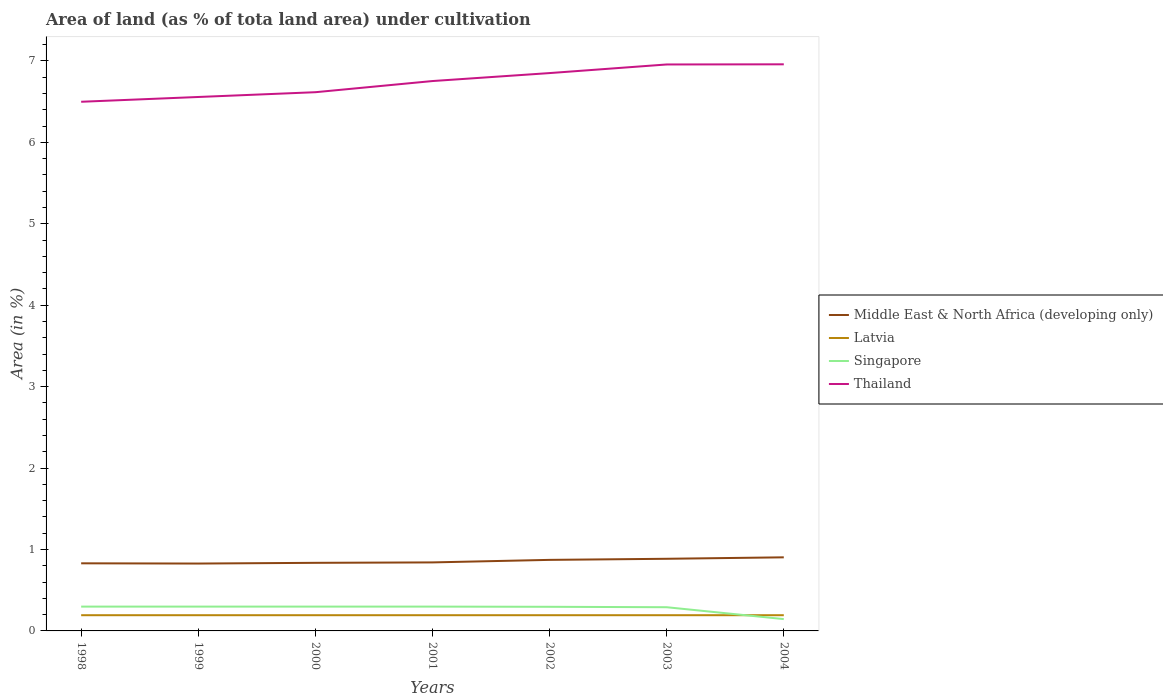Does the line corresponding to Middle East & North Africa (developing only) intersect with the line corresponding to Latvia?
Ensure brevity in your answer.  No. Across all years, what is the maximum percentage of land under cultivation in Latvia?
Keep it short and to the point. 0.19. What is the total percentage of land under cultivation in Thailand in the graph?
Your answer should be very brief. -0.06. What is the difference between the highest and the second highest percentage of land under cultivation in Middle East & North Africa (developing only)?
Give a very brief answer. 0.08. What is the difference between the highest and the lowest percentage of land under cultivation in Thailand?
Your answer should be compact. 4. How many years are there in the graph?
Provide a succinct answer. 7. Are the values on the major ticks of Y-axis written in scientific E-notation?
Your answer should be compact. No. Does the graph contain any zero values?
Make the answer very short. No. What is the title of the graph?
Offer a very short reply. Area of land (as % of tota land area) under cultivation. What is the label or title of the X-axis?
Keep it short and to the point. Years. What is the label or title of the Y-axis?
Provide a short and direct response. Area (in %). What is the Area (in %) in Middle East & North Africa (developing only) in 1998?
Ensure brevity in your answer.  0.83. What is the Area (in %) in Latvia in 1998?
Ensure brevity in your answer.  0.19. What is the Area (in %) of Singapore in 1998?
Make the answer very short. 0.3. What is the Area (in %) in Thailand in 1998?
Your answer should be compact. 6.5. What is the Area (in %) of Middle East & North Africa (developing only) in 1999?
Your answer should be compact. 0.83. What is the Area (in %) in Latvia in 1999?
Ensure brevity in your answer.  0.19. What is the Area (in %) of Singapore in 1999?
Offer a very short reply. 0.3. What is the Area (in %) of Thailand in 1999?
Offer a very short reply. 6.56. What is the Area (in %) of Middle East & North Africa (developing only) in 2000?
Offer a very short reply. 0.84. What is the Area (in %) in Latvia in 2000?
Make the answer very short. 0.19. What is the Area (in %) of Singapore in 2000?
Give a very brief answer. 0.3. What is the Area (in %) in Thailand in 2000?
Your answer should be very brief. 6.62. What is the Area (in %) in Middle East & North Africa (developing only) in 2001?
Provide a succinct answer. 0.84. What is the Area (in %) of Latvia in 2001?
Offer a terse response. 0.19. What is the Area (in %) of Singapore in 2001?
Ensure brevity in your answer.  0.3. What is the Area (in %) of Thailand in 2001?
Offer a very short reply. 6.75. What is the Area (in %) of Middle East & North Africa (developing only) in 2002?
Provide a succinct answer. 0.87. What is the Area (in %) in Latvia in 2002?
Keep it short and to the point. 0.19. What is the Area (in %) in Singapore in 2002?
Provide a short and direct response. 0.3. What is the Area (in %) in Thailand in 2002?
Give a very brief answer. 6.85. What is the Area (in %) in Middle East & North Africa (developing only) in 2003?
Offer a very short reply. 0.89. What is the Area (in %) of Latvia in 2003?
Ensure brevity in your answer.  0.19. What is the Area (in %) of Singapore in 2003?
Offer a terse response. 0.29. What is the Area (in %) in Thailand in 2003?
Your answer should be compact. 6.96. What is the Area (in %) in Middle East & North Africa (developing only) in 2004?
Your answer should be very brief. 0.9. What is the Area (in %) of Latvia in 2004?
Keep it short and to the point. 0.19. What is the Area (in %) of Singapore in 2004?
Offer a terse response. 0.15. What is the Area (in %) in Thailand in 2004?
Provide a succinct answer. 6.96. Across all years, what is the maximum Area (in %) in Middle East & North Africa (developing only)?
Offer a very short reply. 0.9. Across all years, what is the maximum Area (in %) of Latvia?
Your answer should be very brief. 0.19. Across all years, what is the maximum Area (in %) in Singapore?
Provide a succinct answer. 0.3. Across all years, what is the maximum Area (in %) in Thailand?
Your answer should be very brief. 6.96. Across all years, what is the minimum Area (in %) of Middle East & North Africa (developing only)?
Offer a terse response. 0.83. Across all years, what is the minimum Area (in %) of Latvia?
Offer a very short reply. 0.19. Across all years, what is the minimum Area (in %) of Singapore?
Keep it short and to the point. 0.15. Across all years, what is the minimum Area (in %) in Thailand?
Provide a succinct answer. 6.5. What is the total Area (in %) in Middle East & North Africa (developing only) in the graph?
Provide a succinct answer. 6. What is the total Area (in %) of Latvia in the graph?
Keep it short and to the point. 1.35. What is the total Area (in %) in Singapore in the graph?
Keep it short and to the point. 1.93. What is the total Area (in %) of Thailand in the graph?
Keep it short and to the point. 47.19. What is the difference between the Area (in %) of Middle East & North Africa (developing only) in 1998 and that in 1999?
Give a very brief answer. 0. What is the difference between the Area (in %) of Singapore in 1998 and that in 1999?
Offer a very short reply. 0. What is the difference between the Area (in %) in Thailand in 1998 and that in 1999?
Your answer should be compact. -0.06. What is the difference between the Area (in %) of Middle East & North Africa (developing only) in 1998 and that in 2000?
Offer a terse response. -0.01. What is the difference between the Area (in %) of Latvia in 1998 and that in 2000?
Offer a terse response. 0. What is the difference between the Area (in %) in Thailand in 1998 and that in 2000?
Your response must be concise. -0.12. What is the difference between the Area (in %) in Middle East & North Africa (developing only) in 1998 and that in 2001?
Make the answer very short. -0.01. What is the difference between the Area (in %) of Singapore in 1998 and that in 2001?
Your response must be concise. 0. What is the difference between the Area (in %) of Thailand in 1998 and that in 2001?
Offer a very short reply. -0.25. What is the difference between the Area (in %) in Middle East & North Africa (developing only) in 1998 and that in 2002?
Your answer should be compact. -0.04. What is the difference between the Area (in %) in Latvia in 1998 and that in 2002?
Give a very brief answer. 0. What is the difference between the Area (in %) of Singapore in 1998 and that in 2002?
Your response must be concise. 0. What is the difference between the Area (in %) in Thailand in 1998 and that in 2002?
Make the answer very short. -0.35. What is the difference between the Area (in %) in Middle East & North Africa (developing only) in 1998 and that in 2003?
Offer a very short reply. -0.06. What is the difference between the Area (in %) in Latvia in 1998 and that in 2003?
Offer a terse response. 0. What is the difference between the Area (in %) in Singapore in 1998 and that in 2003?
Your answer should be very brief. 0.01. What is the difference between the Area (in %) of Thailand in 1998 and that in 2003?
Your answer should be very brief. -0.46. What is the difference between the Area (in %) of Middle East & North Africa (developing only) in 1998 and that in 2004?
Offer a terse response. -0.07. What is the difference between the Area (in %) of Latvia in 1998 and that in 2004?
Your answer should be compact. 0. What is the difference between the Area (in %) in Singapore in 1998 and that in 2004?
Give a very brief answer. 0.15. What is the difference between the Area (in %) in Thailand in 1998 and that in 2004?
Give a very brief answer. -0.46. What is the difference between the Area (in %) of Middle East & North Africa (developing only) in 1999 and that in 2000?
Ensure brevity in your answer.  -0.01. What is the difference between the Area (in %) of Latvia in 1999 and that in 2000?
Offer a terse response. 0. What is the difference between the Area (in %) in Singapore in 1999 and that in 2000?
Offer a very short reply. 0. What is the difference between the Area (in %) of Thailand in 1999 and that in 2000?
Provide a succinct answer. -0.06. What is the difference between the Area (in %) in Middle East & North Africa (developing only) in 1999 and that in 2001?
Your answer should be compact. -0.01. What is the difference between the Area (in %) of Singapore in 1999 and that in 2001?
Provide a succinct answer. 0. What is the difference between the Area (in %) in Thailand in 1999 and that in 2001?
Ensure brevity in your answer.  -0.2. What is the difference between the Area (in %) in Middle East & North Africa (developing only) in 1999 and that in 2002?
Your response must be concise. -0.05. What is the difference between the Area (in %) of Singapore in 1999 and that in 2002?
Make the answer very short. 0. What is the difference between the Area (in %) of Thailand in 1999 and that in 2002?
Keep it short and to the point. -0.29. What is the difference between the Area (in %) of Middle East & North Africa (developing only) in 1999 and that in 2003?
Your answer should be compact. -0.06. What is the difference between the Area (in %) of Singapore in 1999 and that in 2003?
Offer a terse response. 0.01. What is the difference between the Area (in %) in Thailand in 1999 and that in 2003?
Offer a terse response. -0.4. What is the difference between the Area (in %) of Middle East & North Africa (developing only) in 1999 and that in 2004?
Give a very brief answer. -0.08. What is the difference between the Area (in %) of Singapore in 1999 and that in 2004?
Provide a short and direct response. 0.15. What is the difference between the Area (in %) of Thailand in 1999 and that in 2004?
Offer a terse response. -0.4. What is the difference between the Area (in %) of Middle East & North Africa (developing only) in 2000 and that in 2001?
Provide a short and direct response. -0.01. What is the difference between the Area (in %) in Singapore in 2000 and that in 2001?
Your response must be concise. 0. What is the difference between the Area (in %) of Thailand in 2000 and that in 2001?
Provide a succinct answer. -0.14. What is the difference between the Area (in %) in Middle East & North Africa (developing only) in 2000 and that in 2002?
Ensure brevity in your answer.  -0.04. What is the difference between the Area (in %) of Latvia in 2000 and that in 2002?
Offer a very short reply. 0. What is the difference between the Area (in %) of Singapore in 2000 and that in 2002?
Give a very brief answer. 0. What is the difference between the Area (in %) of Thailand in 2000 and that in 2002?
Make the answer very short. -0.23. What is the difference between the Area (in %) in Middle East & North Africa (developing only) in 2000 and that in 2003?
Your answer should be compact. -0.05. What is the difference between the Area (in %) of Singapore in 2000 and that in 2003?
Keep it short and to the point. 0.01. What is the difference between the Area (in %) in Thailand in 2000 and that in 2003?
Your answer should be very brief. -0.34. What is the difference between the Area (in %) in Middle East & North Africa (developing only) in 2000 and that in 2004?
Keep it short and to the point. -0.07. What is the difference between the Area (in %) of Singapore in 2000 and that in 2004?
Your response must be concise. 0.15. What is the difference between the Area (in %) in Thailand in 2000 and that in 2004?
Make the answer very short. -0.34. What is the difference between the Area (in %) in Middle East & North Africa (developing only) in 2001 and that in 2002?
Keep it short and to the point. -0.03. What is the difference between the Area (in %) in Latvia in 2001 and that in 2002?
Make the answer very short. 0. What is the difference between the Area (in %) in Singapore in 2001 and that in 2002?
Offer a terse response. 0. What is the difference between the Area (in %) of Thailand in 2001 and that in 2002?
Provide a succinct answer. -0.1. What is the difference between the Area (in %) of Middle East & North Africa (developing only) in 2001 and that in 2003?
Keep it short and to the point. -0.04. What is the difference between the Area (in %) in Singapore in 2001 and that in 2003?
Your response must be concise. 0.01. What is the difference between the Area (in %) of Thailand in 2001 and that in 2003?
Offer a terse response. -0.2. What is the difference between the Area (in %) in Middle East & North Africa (developing only) in 2001 and that in 2004?
Provide a succinct answer. -0.06. What is the difference between the Area (in %) in Latvia in 2001 and that in 2004?
Give a very brief answer. 0. What is the difference between the Area (in %) in Singapore in 2001 and that in 2004?
Offer a terse response. 0.15. What is the difference between the Area (in %) in Thailand in 2001 and that in 2004?
Provide a short and direct response. -0.21. What is the difference between the Area (in %) of Middle East & North Africa (developing only) in 2002 and that in 2003?
Your answer should be compact. -0.01. What is the difference between the Area (in %) in Singapore in 2002 and that in 2003?
Your answer should be very brief. 0.01. What is the difference between the Area (in %) of Thailand in 2002 and that in 2003?
Keep it short and to the point. -0.11. What is the difference between the Area (in %) in Middle East & North Africa (developing only) in 2002 and that in 2004?
Your answer should be compact. -0.03. What is the difference between the Area (in %) in Singapore in 2002 and that in 2004?
Offer a very short reply. 0.15. What is the difference between the Area (in %) of Thailand in 2002 and that in 2004?
Give a very brief answer. -0.11. What is the difference between the Area (in %) in Middle East & North Africa (developing only) in 2003 and that in 2004?
Keep it short and to the point. -0.02. What is the difference between the Area (in %) of Singapore in 2003 and that in 2004?
Provide a short and direct response. 0.15. What is the difference between the Area (in %) in Thailand in 2003 and that in 2004?
Keep it short and to the point. -0. What is the difference between the Area (in %) of Middle East & North Africa (developing only) in 1998 and the Area (in %) of Latvia in 1999?
Make the answer very short. 0.64. What is the difference between the Area (in %) of Middle East & North Africa (developing only) in 1998 and the Area (in %) of Singapore in 1999?
Ensure brevity in your answer.  0.53. What is the difference between the Area (in %) in Middle East & North Africa (developing only) in 1998 and the Area (in %) in Thailand in 1999?
Ensure brevity in your answer.  -5.73. What is the difference between the Area (in %) in Latvia in 1998 and the Area (in %) in Singapore in 1999?
Your answer should be very brief. -0.11. What is the difference between the Area (in %) of Latvia in 1998 and the Area (in %) of Thailand in 1999?
Your answer should be very brief. -6.36. What is the difference between the Area (in %) in Singapore in 1998 and the Area (in %) in Thailand in 1999?
Offer a terse response. -6.26. What is the difference between the Area (in %) in Middle East & North Africa (developing only) in 1998 and the Area (in %) in Latvia in 2000?
Give a very brief answer. 0.64. What is the difference between the Area (in %) of Middle East & North Africa (developing only) in 1998 and the Area (in %) of Singapore in 2000?
Give a very brief answer. 0.53. What is the difference between the Area (in %) in Middle East & North Africa (developing only) in 1998 and the Area (in %) in Thailand in 2000?
Provide a succinct answer. -5.79. What is the difference between the Area (in %) of Latvia in 1998 and the Area (in %) of Singapore in 2000?
Provide a short and direct response. -0.11. What is the difference between the Area (in %) of Latvia in 1998 and the Area (in %) of Thailand in 2000?
Offer a very short reply. -6.42. What is the difference between the Area (in %) of Singapore in 1998 and the Area (in %) of Thailand in 2000?
Your answer should be very brief. -6.32. What is the difference between the Area (in %) in Middle East & North Africa (developing only) in 1998 and the Area (in %) in Latvia in 2001?
Your response must be concise. 0.64. What is the difference between the Area (in %) in Middle East & North Africa (developing only) in 1998 and the Area (in %) in Singapore in 2001?
Your answer should be compact. 0.53. What is the difference between the Area (in %) of Middle East & North Africa (developing only) in 1998 and the Area (in %) of Thailand in 2001?
Ensure brevity in your answer.  -5.92. What is the difference between the Area (in %) in Latvia in 1998 and the Area (in %) in Singapore in 2001?
Make the answer very short. -0.11. What is the difference between the Area (in %) of Latvia in 1998 and the Area (in %) of Thailand in 2001?
Give a very brief answer. -6.56. What is the difference between the Area (in %) of Singapore in 1998 and the Area (in %) of Thailand in 2001?
Provide a succinct answer. -6.45. What is the difference between the Area (in %) of Middle East & North Africa (developing only) in 1998 and the Area (in %) of Latvia in 2002?
Give a very brief answer. 0.64. What is the difference between the Area (in %) of Middle East & North Africa (developing only) in 1998 and the Area (in %) of Singapore in 2002?
Your answer should be very brief. 0.53. What is the difference between the Area (in %) of Middle East & North Africa (developing only) in 1998 and the Area (in %) of Thailand in 2002?
Give a very brief answer. -6.02. What is the difference between the Area (in %) of Latvia in 1998 and the Area (in %) of Singapore in 2002?
Your answer should be very brief. -0.1. What is the difference between the Area (in %) in Latvia in 1998 and the Area (in %) in Thailand in 2002?
Your answer should be very brief. -6.66. What is the difference between the Area (in %) of Singapore in 1998 and the Area (in %) of Thailand in 2002?
Your response must be concise. -6.55. What is the difference between the Area (in %) of Middle East & North Africa (developing only) in 1998 and the Area (in %) of Latvia in 2003?
Provide a succinct answer. 0.64. What is the difference between the Area (in %) of Middle East & North Africa (developing only) in 1998 and the Area (in %) of Singapore in 2003?
Ensure brevity in your answer.  0.54. What is the difference between the Area (in %) in Middle East & North Africa (developing only) in 1998 and the Area (in %) in Thailand in 2003?
Make the answer very short. -6.13. What is the difference between the Area (in %) of Latvia in 1998 and the Area (in %) of Singapore in 2003?
Offer a very short reply. -0.1. What is the difference between the Area (in %) of Latvia in 1998 and the Area (in %) of Thailand in 2003?
Ensure brevity in your answer.  -6.76. What is the difference between the Area (in %) of Singapore in 1998 and the Area (in %) of Thailand in 2003?
Provide a succinct answer. -6.66. What is the difference between the Area (in %) of Middle East & North Africa (developing only) in 1998 and the Area (in %) of Latvia in 2004?
Ensure brevity in your answer.  0.64. What is the difference between the Area (in %) of Middle East & North Africa (developing only) in 1998 and the Area (in %) of Singapore in 2004?
Ensure brevity in your answer.  0.69. What is the difference between the Area (in %) in Middle East & North Africa (developing only) in 1998 and the Area (in %) in Thailand in 2004?
Give a very brief answer. -6.13. What is the difference between the Area (in %) of Latvia in 1998 and the Area (in %) of Singapore in 2004?
Keep it short and to the point. 0.05. What is the difference between the Area (in %) of Latvia in 1998 and the Area (in %) of Thailand in 2004?
Keep it short and to the point. -6.77. What is the difference between the Area (in %) in Singapore in 1998 and the Area (in %) in Thailand in 2004?
Make the answer very short. -6.66. What is the difference between the Area (in %) in Middle East & North Africa (developing only) in 1999 and the Area (in %) in Latvia in 2000?
Offer a very short reply. 0.63. What is the difference between the Area (in %) of Middle East & North Africa (developing only) in 1999 and the Area (in %) of Singapore in 2000?
Provide a succinct answer. 0.53. What is the difference between the Area (in %) of Middle East & North Africa (developing only) in 1999 and the Area (in %) of Thailand in 2000?
Your answer should be very brief. -5.79. What is the difference between the Area (in %) in Latvia in 1999 and the Area (in %) in Singapore in 2000?
Offer a very short reply. -0.11. What is the difference between the Area (in %) in Latvia in 1999 and the Area (in %) in Thailand in 2000?
Offer a very short reply. -6.42. What is the difference between the Area (in %) in Singapore in 1999 and the Area (in %) in Thailand in 2000?
Offer a terse response. -6.32. What is the difference between the Area (in %) in Middle East & North Africa (developing only) in 1999 and the Area (in %) in Latvia in 2001?
Provide a succinct answer. 0.63. What is the difference between the Area (in %) in Middle East & North Africa (developing only) in 1999 and the Area (in %) in Singapore in 2001?
Offer a terse response. 0.53. What is the difference between the Area (in %) of Middle East & North Africa (developing only) in 1999 and the Area (in %) of Thailand in 2001?
Offer a terse response. -5.93. What is the difference between the Area (in %) of Latvia in 1999 and the Area (in %) of Singapore in 2001?
Provide a succinct answer. -0.11. What is the difference between the Area (in %) in Latvia in 1999 and the Area (in %) in Thailand in 2001?
Offer a terse response. -6.56. What is the difference between the Area (in %) of Singapore in 1999 and the Area (in %) of Thailand in 2001?
Provide a short and direct response. -6.45. What is the difference between the Area (in %) of Middle East & North Africa (developing only) in 1999 and the Area (in %) of Latvia in 2002?
Your response must be concise. 0.63. What is the difference between the Area (in %) of Middle East & North Africa (developing only) in 1999 and the Area (in %) of Singapore in 2002?
Give a very brief answer. 0.53. What is the difference between the Area (in %) in Middle East & North Africa (developing only) in 1999 and the Area (in %) in Thailand in 2002?
Your response must be concise. -6.02. What is the difference between the Area (in %) in Latvia in 1999 and the Area (in %) in Singapore in 2002?
Give a very brief answer. -0.1. What is the difference between the Area (in %) of Latvia in 1999 and the Area (in %) of Thailand in 2002?
Your answer should be compact. -6.66. What is the difference between the Area (in %) of Singapore in 1999 and the Area (in %) of Thailand in 2002?
Offer a very short reply. -6.55. What is the difference between the Area (in %) of Middle East & North Africa (developing only) in 1999 and the Area (in %) of Latvia in 2003?
Make the answer very short. 0.63. What is the difference between the Area (in %) of Middle East & North Africa (developing only) in 1999 and the Area (in %) of Singapore in 2003?
Give a very brief answer. 0.54. What is the difference between the Area (in %) of Middle East & North Africa (developing only) in 1999 and the Area (in %) of Thailand in 2003?
Your answer should be very brief. -6.13. What is the difference between the Area (in %) in Latvia in 1999 and the Area (in %) in Singapore in 2003?
Your response must be concise. -0.1. What is the difference between the Area (in %) in Latvia in 1999 and the Area (in %) in Thailand in 2003?
Provide a short and direct response. -6.76. What is the difference between the Area (in %) of Singapore in 1999 and the Area (in %) of Thailand in 2003?
Your response must be concise. -6.66. What is the difference between the Area (in %) in Middle East & North Africa (developing only) in 1999 and the Area (in %) in Latvia in 2004?
Keep it short and to the point. 0.63. What is the difference between the Area (in %) in Middle East & North Africa (developing only) in 1999 and the Area (in %) in Singapore in 2004?
Your response must be concise. 0.68. What is the difference between the Area (in %) in Middle East & North Africa (developing only) in 1999 and the Area (in %) in Thailand in 2004?
Offer a very short reply. -6.13. What is the difference between the Area (in %) in Latvia in 1999 and the Area (in %) in Singapore in 2004?
Provide a succinct answer. 0.05. What is the difference between the Area (in %) of Latvia in 1999 and the Area (in %) of Thailand in 2004?
Your answer should be compact. -6.77. What is the difference between the Area (in %) in Singapore in 1999 and the Area (in %) in Thailand in 2004?
Offer a very short reply. -6.66. What is the difference between the Area (in %) in Middle East & North Africa (developing only) in 2000 and the Area (in %) in Latvia in 2001?
Offer a very short reply. 0.64. What is the difference between the Area (in %) of Middle East & North Africa (developing only) in 2000 and the Area (in %) of Singapore in 2001?
Ensure brevity in your answer.  0.54. What is the difference between the Area (in %) in Middle East & North Africa (developing only) in 2000 and the Area (in %) in Thailand in 2001?
Keep it short and to the point. -5.92. What is the difference between the Area (in %) of Latvia in 2000 and the Area (in %) of Singapore in 2001?
Give a very brief answer. -0.11. What is the difference between the Area (in %) in Latvia in 2000 and the Area (in %) in Thailand in 2001?
Provide a succinct answer. -6.56. What is the difference between the Area (in %) of Singapore in 2000 and the Area (in %) of Thailand in 2001?
Ensure brevity in your answer.  -6.45. What is the difference between the Area (in %) of Middle East & North Africa (developing only) in 2000 and the Area (in %) of Latvia in 2002?
Offer a terse response. 0.64. What is the difference between the Area (in %) of Middle East & North Africa (developing only) in 2000 and the Area (in %) of Singapore in 2002?
Your answer should be very brief. 0.54. What is the difference between the Area (in %) of Middle East & North Africa (developing only) in 2000 and the Area (in %) of Thailand in 2002?
Provide a short and direct response. -6.01. What is the difference between the Area (in %) of Latvia in 2000 and the Area (in %) of Singapore in 2002?
Your response must be concise. -0.1. What is the difference between the Area (in %) of Latvia in 2000 and the Area (in %) of Thailand in 2002?
Ensure brevity in your answer.  -6.66. What is the difference between the Area (in %) of Singapore in 2000 and the Area (in %) of Thailand in 2002?
Your answer should be compact. -6.55. What is the difference between the Area (in %) of Middle East & North Africa (developing only) in 2000 and the Area (in %) of Latvia in 2003?
Keep it short and to the point. 0.64. What is the difference between the Area (in %) of Middle East & North Africa (developing only) in 2000 and the Area (in %) of Singapore in 2003?
Offer a very short reply. 0.55. What is the difference between the Area (in %) in Middle East & North Africa (developing only) in 2000 and the Area (in %) in Thailand in 2003?
Offer a very short reply. -6.12. What is the difference between the Area (in %) in Latvia in 2000 and the Area (in %) in Singapore in 2003?
Ensure brevity in your answer.  -0.1. What is the difference between the Area (in %) in Latvia in 2000 and the Area (in %) in Thailand in 2003?
Your response must be concise. -6.76. What is the difference between the Area (in %) of Singapore in 2000 and the Area (in %) of Thailand in 2003?
Give a very brief answer. -6.66. What is the difference between the Area (in %) in Middle East & North Africa (developing only) in 2000 and the Area (in %) in Latvia in 2004?
Provide a succinct answer. 0.64. What is the difference between the Area (in %) in Middle East & North Africa (developing only) in 2000 and the Area (in %) in Singapore in 2004?
Your answer should be very brief. 0.69. What is the difference between the Area (in %) of Middle East & North Africa (developing only) in 2000 and the Area (in %) of Thailand in 2004?
Offer a very short reply. -6.12. What is the difference between the Area (in %) of Latvia in 2000 and the Area (in %) of Singapore in 2004?
Make the answer very short. 0.05. What is the difference between the Area (in %) of Latvia in 2000 and the Area (in %) of Thailand in 2004?
Provide a short and direct response. -6.77. What is the difference between the Area (in %) in Singapore in 2000 and the Area (in %) in Thailand in 2004?
Offer a very short reply. -6.66. What is the difference between the Area (in %) of Middle East & North Africa (developing only) in 2001 and the Area (in %) of Latvia in 2002?
Provide a succinct answer. 0.65. What is the difference between the Area (in %) in Middle East & North Africa (developing only) in 2001 and the Area (in %) in Singapore in 2002?
Provide a succinct answer. 0.55. What is the difference between the Area (in %) in Middle East & North Africa (developing only) in 2001 and the Area (in %) in Thailand in 2002?
Offer a terse response. -6.01. What is the difference between the Area (in %) in Latvia in 2001 and the Area (in %) in Singapore in 2002?
Your answer should be compact. -0.1. What is the difference between the Area (in %) of Latvia in 2001 and the Area (in %) of Thailand in 2002?
Ensure brevity in your answer.  -6.66. What is the difference between the Area (in %) in Singapore in 2001 and the Area (in %) in Thailand in 2002?
Ensure brevity in your answer.  -6.55. What is the difference between the Area (in %) in Middle East & North Africa (developing only) in 2001 and the Area (in %) in Latvia in 2003?
Offer a very short reply. 0.65. What is the difference between the Area (in %) in Middle East & North Africa (developing only) in 2001 and the Area (in %) in Singapore in 2003?
Provide a short and direct response. 0.55. What is the difference between the Area (in %) in Middle East & North Africa (developing only) in 2001 and the Area (in %) in Thailand in 2003?
Your answer should be very brief. -6.12. What is the difference between the Area (in %) of Latvia in 2001 and the Area (in %) of Singapore in 2003?
Provide a short and direct response. -0.1. What is the difference between the Area (in %) in Latvia in 2001 and the Area (in %) in Thailand in 2003?
Offer a terse response. -6.76. What is the difference between the Area (in %) of Singapore in 2001 and the Area (in %) of Thailand in 2003?
Give a very brief answer. -6.66. What is the difference between the Area (in %) in Middle East & North Africa (developing only) in 2001 and the Area (in %) in Latvia in 2004?
Keep it short and to the point. 0.65. What is the difference between the Area (in %) in Middle East & North Africa (developing only) in 2001 and the Area (in %) in Singapore in 2004?
Your answer should be very brief. 0.7. What is the difference between the Area (in %) of Middle East & North Africa (developing only) in 2001 and the Area (in %) of Thailand in 2004?
Provide a short and direct response. -6.12. What is the difference between the Area (in %) of Latvia in 2001 and the Area (in %) of Singapore in 2004?
Offer a terse response. 0.05. What is the difference between the Area (in %) in Latvia in 2001 and the Area (in %) in Thailand in 2004?
Give a very brief answer. -6.77. What is the difference between the Area (in %) of Singapore in 2001 and the Area (in %) of Thailand in 2004?
Keep it short and to the point. -6.66. What is the difference between the Area (in %) of Middle East & North Africa (developing only) in 2002 and the Area (in %) of Latvia in 2003?
Provide a short and direct response. 0.68. What is the difference between the Area (in %) of Middle East & North Africa (developing only) in 2002 and the Area (in %) of Singapore in 2003?
Provide a short and direct response. 0.58. What is the difference between the Area (in %) of Middle East & North Africa (developing only) in 2002 and the Area (in %) of Thailand in 2003?
Give a very brief answer. -6.08. What is the difference between the Area (in %) in Latvia in 2002 and the Area (in %) in Singapore in 2003?
Make the answer very short. -0.1. What is the difference between the Area (in %) in Latvia in 2002 and the Area (in %) in Thailand in 2003?
Ensure brevity in your answer.  -6.76. What is the difference between the Area (in %) of Singapore in 2002 and the Area (in %) of Thailand in 2003?
Offer a very short reply. -6.66. What is the difference between the Area (in %) of Middle East & North Africa (developing only) in 2002 and the Area (in %) of Latvia in 2004?
Offer a terse response. 0.68. What is the difference between the Area (in %) in Middle East & North Africa (developing only) in 2002 and the Area (in %) in Singapore in 2004?
Give a very brief answer. 0.73. What is the difference between the Area (in %) in Middle East & North Africa (developing only) in 2002 and the Area (in %) in Thailand in 2004?
Provide a short and direct response. -6.09. What is the difference between the Area (in %) in Latvia in 2002 and the Area (in %) in Singapore in 2004?
Give a very brief answer. 0.05. What is the difference between the Area (in %) of Latvia in 2002 and the Area (in %) of Thailand in 2004?
Ensure brevity in your answer.  -6.77. What is the difference between the Area (in %) in Singapore in 2002 and the Area (in %) in Thailand in 2004?
Make the answer very short. -6.66. What is the difference between the Area (in %) of Middle East & North Africa (developing only) in 2003 and the Area (in %) of Latvia in 2004?
Make the answer very short. 0.69. What is the difference between the Area (in %) of Middle East & North Africa (developing only) in 2003 and the Area (in %) of Singapore in 2004?
Your answer should be very brief. 0.74. What is the difference between the Area (in %) of Middle East & North Africa (developing only) in 2003 and the Area (in %) of Thailand in 2004?
Offer a terse response. -6.07. What is the difference between the Area (in %) in Latvia in 2003 and the Area (in %) in Singapore in 2004?
Offer a terse response. 0.05. What is the difference between the Area (in %) in Latvia in 2003 and the Area (in %) in Thailand in 2004?
Ensure brevity in your answer.  -6.77. What is the difference between the Area (in %) in Singapore in 2003 and the Area (in %) in Thailand in 2004?
Provide a short and direct response. -6.67. What is the average Area (in %) in Middle East & North Africa (developing only) per year?
Give a very brief answer. 0.86. What is the average Area (in %) of Latvia per year?
Give a very brief answer. 0.19. What is the average Area (in %) of Singapore per year?
Make the answer very short. 0.28. What is the average Area (in %) of Thailand per year?
Keep it short and to the point. 6.74. In the year 1998, what is the difference between the Area (in %) of Middle East & North Africa (developing only) and Area (in %) of Latvia?
Give a very brief answer. 0.64. In the year 1998, what is the difference between the Area (in %) in Middle East & North Africa (developing only) and Area (in %) in Singapore?
Provide a succinct answer. 0.53. In the year 1998, what is the difference between the Area (in %) of Middle East & North Africa (developing only) and Area (in %) of Thailand?
Offer a terse response. -5.67. In the year 1998, what is the difference between the Area (in %) in Latvia and Area (in %) in Singapore?
Offer a terse response. -0.11. In the year 1998, what is the difference between the Area (in %) in Latvia and Area (in %) in Thailand?
Ensure brevity in your answer.  -6.31. In the year 1999, what is the difference between the Area (in %) of Middle East & North Africa (developing only) and Area (in %) of Latvia?
Give a very brief answer. 0.63. In the year 1999, what is the difference between the Area (in %) in Middle East & North Africa (developing only) and Area (in %) in Singapore?
Your answer should be very brief. 0.53. In the year 1999, what is the difference between the Area (in %) of Middle East & North Africa (developing only) and Area (in %) of Thailand?
Provide a short and direct response. -5.73. In the year 1999, what is the difference between the Area (in %) of Latvia and Area (in %) of Singapore?
Make the answer very short. -0.11. In the year 1999, what is the difference between the Area (in %) in Latvia and Area (in %) in Thailand?
Your response must be concise. -6.36. In the year 1999, what is the difference between the Area (in %) in Singapore and Area (in %) in Thailand?
Offer a very short reply. -6.26. In the year 2000, what is the difference between the Area (in %) of Middle East & North Africa (developing only) and Area (in %) of Latvia?
Your response must be concise. 0.64. In the year 2000, what is the difference between the Area (in %) of Middle East & North Africa (developing only) and Area (in %) of Singapore?
Give a very brief answer. 0.54. In the year 2000, what is the difference between the Area (in %) of Middle East & North Africa (developing only) and Area (in %) of Thailand?
Provide a short and direct response. -5.78. In the year 2000, what is the difference between the Area (in %) in Latvia and Area (in %) in Singapore?
Provide a succinct answer. -0.11. In the year 2000, what is the difference between the Area (in %) in Latvia and Area (in %) in Thailand?
Your answer should be compact. -6.42. In the year 2000, what is the difference between the Area (in %) in Singapore and Area (in %) in Thailand?
Offer a very short reply. -6.32. In the year 2001, what is the difference between the Area (in %) in Middle East & North Africa (developing only) and Area (in %) in Latvia?
Make the answer very short. 0.65. In the year 2001, what is the difference between the Area (in %) in Middle East & North Africa (developing only) and Area (in %) in Singapore?
Provide a short and direct response. 0.54. In the year 2001, what is the difference between the Area (in %) of Middle East & North Africa (developing only) and Area (in %) of Thailand?
Ensure brevity in your answer.  -5.91. In the year 2001, what is the difference between the Area (in %) in Latvia and Area (in %) in Singapore?
Your answer should be compact. -0.11. In the year 2001, what is the difference between the Area (in %) in Latvia and Area (in %) in Thailand?
Offer a very short reply. -6.56. In the year 2001, what is the difference between the Area (in %) of Singapore and Area (in %) of Thailand?
Offer a very short reply. -6.45. In the year 2002, what is the difference between the Area (in %) in Middle East & North Africa (developing only) and Area (in %) in Latvia?
Make the answer very short. 0.68. In the year 2002, what is the difference between the Area (in %) in Middle East & North Africa (developing only) and Area (in %) in Singapore?
Your response must be concise. 0.58. In the year 2002, what is the difference between the Area (in %) of Middle East & North Africa (developing only) and Area (in %) of Thailand?
Make the answer very short. -5.98. In the year 2002, what is the difference between the Area (in %) in Latvia and Area (in %) in Singapore?
Offer a terse response. -0.1. In the year 2002, what is the difference between the Area (in %) of Latvia and Area (in %) of Thailand?
Your response must be concise. -6.66. In the year 2002, what is the difference between the Area (in %) of Singapore and Area (in %) of Thailand?
Your answer should be compact. -6.55. In the year 2003, what is the difference between the Area (in %) of Middle East & North Africa (developing only) and Area (in %) of Latvia?
Provide a succinct answer. 0.69. In the year 2003, what is the difference between the Area (in %) in Middle East & North Africa (developing only) and Area (in %) in Singapore?
Offer a terse response. 0.59. In the year 2003, what is the difference between the Area (in %) in Middle East & North Africa (developing only) and Area (in %) in Thailand?
Keep it short and to the point. -6.07. In the year 2003, what is the difference between the Area (in %) in Latvia and Area (in %) in Singapore?
Ensure brevity in your answer.  -0.1. In the year 2003, what is the difference between the Area (in %) in Latvia and Area (in %) in Thailand?
Provide a succinct answer. -6.76. In the year 2003, what is the difference between the Area (in %) in Singapore and Area (in %) in Thailand?
Give a very brief answer. -6.67. In the year 2004, what is the difference between the Area (in %) of Middle East & North Africa (developing only) and Area (in %) of Latvia?
Make the answer very short. 0.71. In the year 2004, what is the difference between the Area (in %) in Middle East & North Africa (developing only) and Area (in %) in Singapore?
Your answer should be very brief. 0.76. In the year 2004, what is the difference between the Area (in %) of Middle East & North Africa (developing only) and Area (in %) of Thailand?
Keep it short and to the point. -6.05. In the year 2004, what is the difference between the Area (in %) in Latvia and Area (in %) in Singapore?
Offer a very short reply. 0.05. In the year 2004, what is the difference between the Area (in %) of Latvia and Area (in %) of Thailand?
Ensure brevity in your answer.  -6.77. In the year 2004, what is the difference between the Area (in %) in Singapore and Area (in %) in Thailand?
Offer a very short reply. -6.81. What is the ratio of the Area (in %) of Latvia in 1998 to that in 1999?
Your answer should be very brief. 1. What is the ratio of the Area (in %) in Singapore in 1998 to that in 1999?
Offer a very short reply. 1. What is the ratio of the Area (in %) in Thailand in 1998 to that in 1999?
Offer a very short reply. 0.99. What is the ratio of the Area (in %) in Latvia in 1998 to that in 2000?
Provide a succinct answer. 1. What is the ratio of the Area (in %) in Singapore in 1998 to that in 2000?
Keep it short and to the point. 1. What is the ratio of the Area (in %) of Thailand in 1998 to that in 2000?
Your response must be concise. 0.98. What is the ratio of the Area (in %) of Middle East & North Africa (developing only) in 1998 to that in 2001?
Your answer should be compact. 0.99. What is the ratio of the Area (in %) of Latvia in 1998 to that in 2001?
Your answer should be compact. 1. What is the ratio of the Area (in %) in Thailand in 1998 to that in 2001?
Your answer should be compact. 0.96. What is the ratio of the Area (in %) of Middle East & North Africa (developing only) in 1998 to that in 2002?
Provide a short and direct response. 0.95. What is the ratio of the Area (in %) in Latvia in 1998 to that in 2002?
Your answer should be very brief. 1. What is the ratio of the Area (in %) in Singapore in 1998 to that in 2002?
Keep it short and to the point. 1.01. What is the ratio of the Area (in %) of Thailand in 1998 to that in 2002?
Provide a short and direct response. 0.95. What is the ratio of the Area (in %) of Middle East & North Africa (developing only) in 1998 to that in 2003?
Offer a very short reply. 0.94. What is the ratio of the Area (in %) of Singapore in 1998 to that in 2003?
Provide a succinct answer. 1.03. What is the ratio of the Area (in %) in Thailand in 1998 to that in 2003?
Offer a very short reply. 0.93. What is the ratio of the Area (in %) in Middle East & North Africa (developing only) in 1998 to that in 2004?
Offer a very short reply. 0.92. What is the ratio of the Area (in %) in Singapore in 1998 to that in 2004?
Offer a terse response. 2.06. What is the ratio of the Area (in %) in Thailand in 1998 to that in 2004?
Provide a succinct answer. 0.93. What is the ratio of the Area (in %) of Middle East & North Africa (developing only) in 1999 to that in 2000?
Your answer should be very brief. 0.99. What is the ratio of the Area (in %) in Middle East & North Africa (developing only) in 1999 to that in 2001?
Provide a succinct answer. 0.98. What is the ratio of the Area (in %) in Singapore in 1999 to that in 2001?
Your response must be concise. 1. What is the ratio of the Area (in %) in Middle East & North Africa (developing only) in 1999 to that in 2002?
Keep it short and to the point. 0.95. What is the ratio of the Area (in %) of Singapore in 1999 to that in 2002?
Make the answer very short. 1.01. What is the ratio of the Area (in %) of Thailand in 1999 to that in 2002?
Provide a short and direct response. 0.96. What is the ratio of the Area (in %) of Middle East & North Africa (developing only) in 1999 to that in 2003?
Keep it short and to the point. 0.93. What is the ratio of the Area (in %) of Singapore in 1999 to that in 2003?
Ensure brevity in your answer.  1.03. What is the ratio of the Area (in %) in Thailand in 1999 to that in 2003?
Offer a terse response. 0.94. What is the ratio of the Area (in %) in Middle East & North Africa (developing only) in 1999 to that in 2004?
Your answer should be compact. 0.92. What is the ratio of the Area (in %) of Latvia in 1999 to that in 2004?
Offer a very short reply. 1. What is the ratio of the Area (in %) in Singapore in 1999 to that in 2004?
Your answer should be compact. 2.06. What is the ratio of the Area (in %) in Thailand in 1999 to that in 2004?
Give a very brief answer. 0.94. What is the ratio of the Area (in %) of Middle East & North Africa (developing only) in 2000 to that in 2001?
Your response must be concise. 0.99. What is the ratio of the Area (in %) of Singapore in 2000 to that in 2001?
Your response must be concise. 1. What is the ratio of the Area (in %) of Thailand in 2000 to that in 2001?
Provide a succinct answer. 0.98. What is the ratio of the Area (in %) of Middle East & North Africa (developing only) in 2000 to that in 2002?
Provide a short and direct response. 0.96. What is the ratio of the Area (in %) of Latvia in 2000 to that in 2002?
Keep it short and to the point. 1. What is the ratio of the Area (in %) in Singapore in 2000 to that in 2002?
Your answer should be very brief. 1.01. What is the ratio of the Area (in %) in Thailand in 2000 to that in 2002?
Your answer should be very brief. 0.97. What is the ratio of the Area (in %) of Middle East & North Africa (developing only) in 2000 to that in 2003?
Your answer should be very brief. 0.94. What is the ratio of the Area (in %) of Singapore in 2000 to that in 2003?
Offer a terse response. 1.03. What is the ratio of the Area (in %) in Thailand in 2000 to that in 2003?
Your answer should be very brief. 0.95. What is the ratio of the Area (in %) of Middle East & North Africa (developing only) in 2000 to that in 2004?
Keep it short and to the point. 0.93. What is the ratio of the Area (in %) in Latvia in 2000 to that in 2004?
Your response must be concise. 1. What is the ratio of the Area (in %) of Singapore in 2000 to that in 2004?
Your response must be concise. 2.06. What is the ratio of the Area (in %) in Thailand in 2000 to that in 2004?
Provide a short and direct response. 0.95. What is the ratio of the Area (in %) of Middle East & North Africa (developing only) in 2001 to that in 2002?
Give a very brief answer. 0.96. What is the ratio of the Area (in %) in Singapore in 2001 to that in 2002?
Provide a short and direct response. 1.01. What is the ratio of the Area (in %) in Thailand in 2001 to that in 2002?
Ensure brevity in your answer.  0.99. What is the ratio of the Area (in %) in Middle East & North Africa (developing only) in 2001 to that in 2003?
Make the answer very short. 0.95. What is the ratio of the Area (in %) of Singapore in 2001 to that in 2003?
Your answer should be very brief. 1.03. What is the ratio of the Area (in %) of Thailand in 2001 to that in 2003?
Give a very brief answer. 0.97. What is the ratio of the Area (in %) of Middle East & North Africa (developing only) in 2001 to that in 2004?
Your answer should be compact. 0.93. What is the ratio of the Area (in %) of Singapore in 2001 to that in 2004?
Your answer should be very brief. 2.06. What is the ratio of the Area (in %) in Thailand in 2001 to that in 2004?
Give a very brief answer. 0.97. What is the ratio of the Area (in %) in Singapore in 2002 to that in 2003?
Give a very brief answer. 1.02. What is the ratio of the Area (in %) in Thailand in 2002 to that in 2003?
Offer a terse response. 0.98. What is the ratio of the Area (in %) in Middle East & North Africa (developing only) in 2002 to that in 2004?
Provide a short and direct response. 0.97. What is the ratio of the Area (in %) of Latvia in 2002 to that in 2004?
Offer a terse response. 1. What is the ratio of the Area (in %) of Singapore in 2002 to that in 2004?
Offer a terse response. 2.04. What is the ratio of the Area (in %) of Thailand in 2002 to that in 2004?
Offer a terse response. 0.98. What is the ratio of the Area (in %) of Middle East & North Africa (developing only) in 2003 to that in 2004?
Your answer should be very brief. 0.98. What is the ratio of the Area (in %) of Latvia in 2003 to that in 2004?
Keep it short and to the point. 1. What is the ratio of the Area (in %) of Singapore in 2003 to that in 2004?
Provide a short and direct response. 2.01. What is the ratio of the Area (in %) of Thailand in 2003 to that in 2004?
Keep it short and to the point. 1. What is the difference between the highest and the second highest Area (in %) of Middle East & North Africa (developing only)?
Offer a very short reply. 0.02. What is the difference between the highest and the second highest Area (in %) of Latvia?
Keep it short and to the point. 0. What is the difference between the highest and the second highest Area (in %) of Thailand?
Offer a terse response. 0. What is the difference between the highest and the lowest Area (in %) of Middle East & North Africa (developing only)?
Ensure brevity in your answer.  0.08. What is the difference between the highest and the lowest Area (in %) of Latvia?
Your answer should be very brief. 0. What is the difference between the highest and the lowest Area (in %) of Singapore?
Provide a succinct answer. 0.15. What is the difference between the highest and the lowest Area (in %) of Thailand?
Make the answer very short. 0.46. 